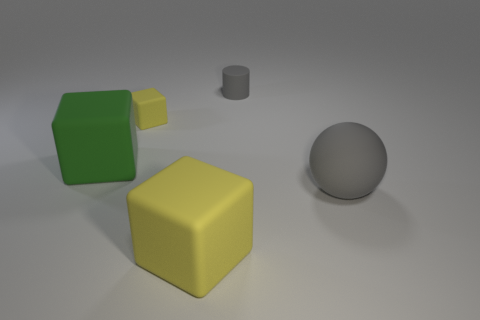Are there any other things that are the same color as the rubber cylinder?
Provide a short and direct response. Yes. What shape is the matte object that is both right of the large yellow cube and in front of the small gray thing?
Ensure brevity in your answer.  Sphere. There is a yellow thing behind the gray sphere; what is its size?
Your answer should be compact. Small. How many big matte blocks are on the left side of the tiny object that is behind the small rubber object left of the tiny gray cylinder?
Offer a terse response. 2. There is a green block; are there any rubber cubes on the right side of it?
Your response must be concise. Yes. How many other objects are the same size as the green matte block?
Make the answer very short. 2. There is a tiny rubber thing that is behind the small yellow matte block; is its shape the same as the large rubber object right of the tiny gray cylinder?
Make the answer very short. No. There is a gray rubber object in front of the tiny gray cylinder that is right of the block that is behind the green thing; what is its shape?
Your answer should be compact. Sphere. What number of other objects are the same shape as the big gray matte thing?
Provide a succinct answer. 0. There is a matte ball that is the same size as the green rubber thing; what color is it?
Provide a short and direct response. Gray. 